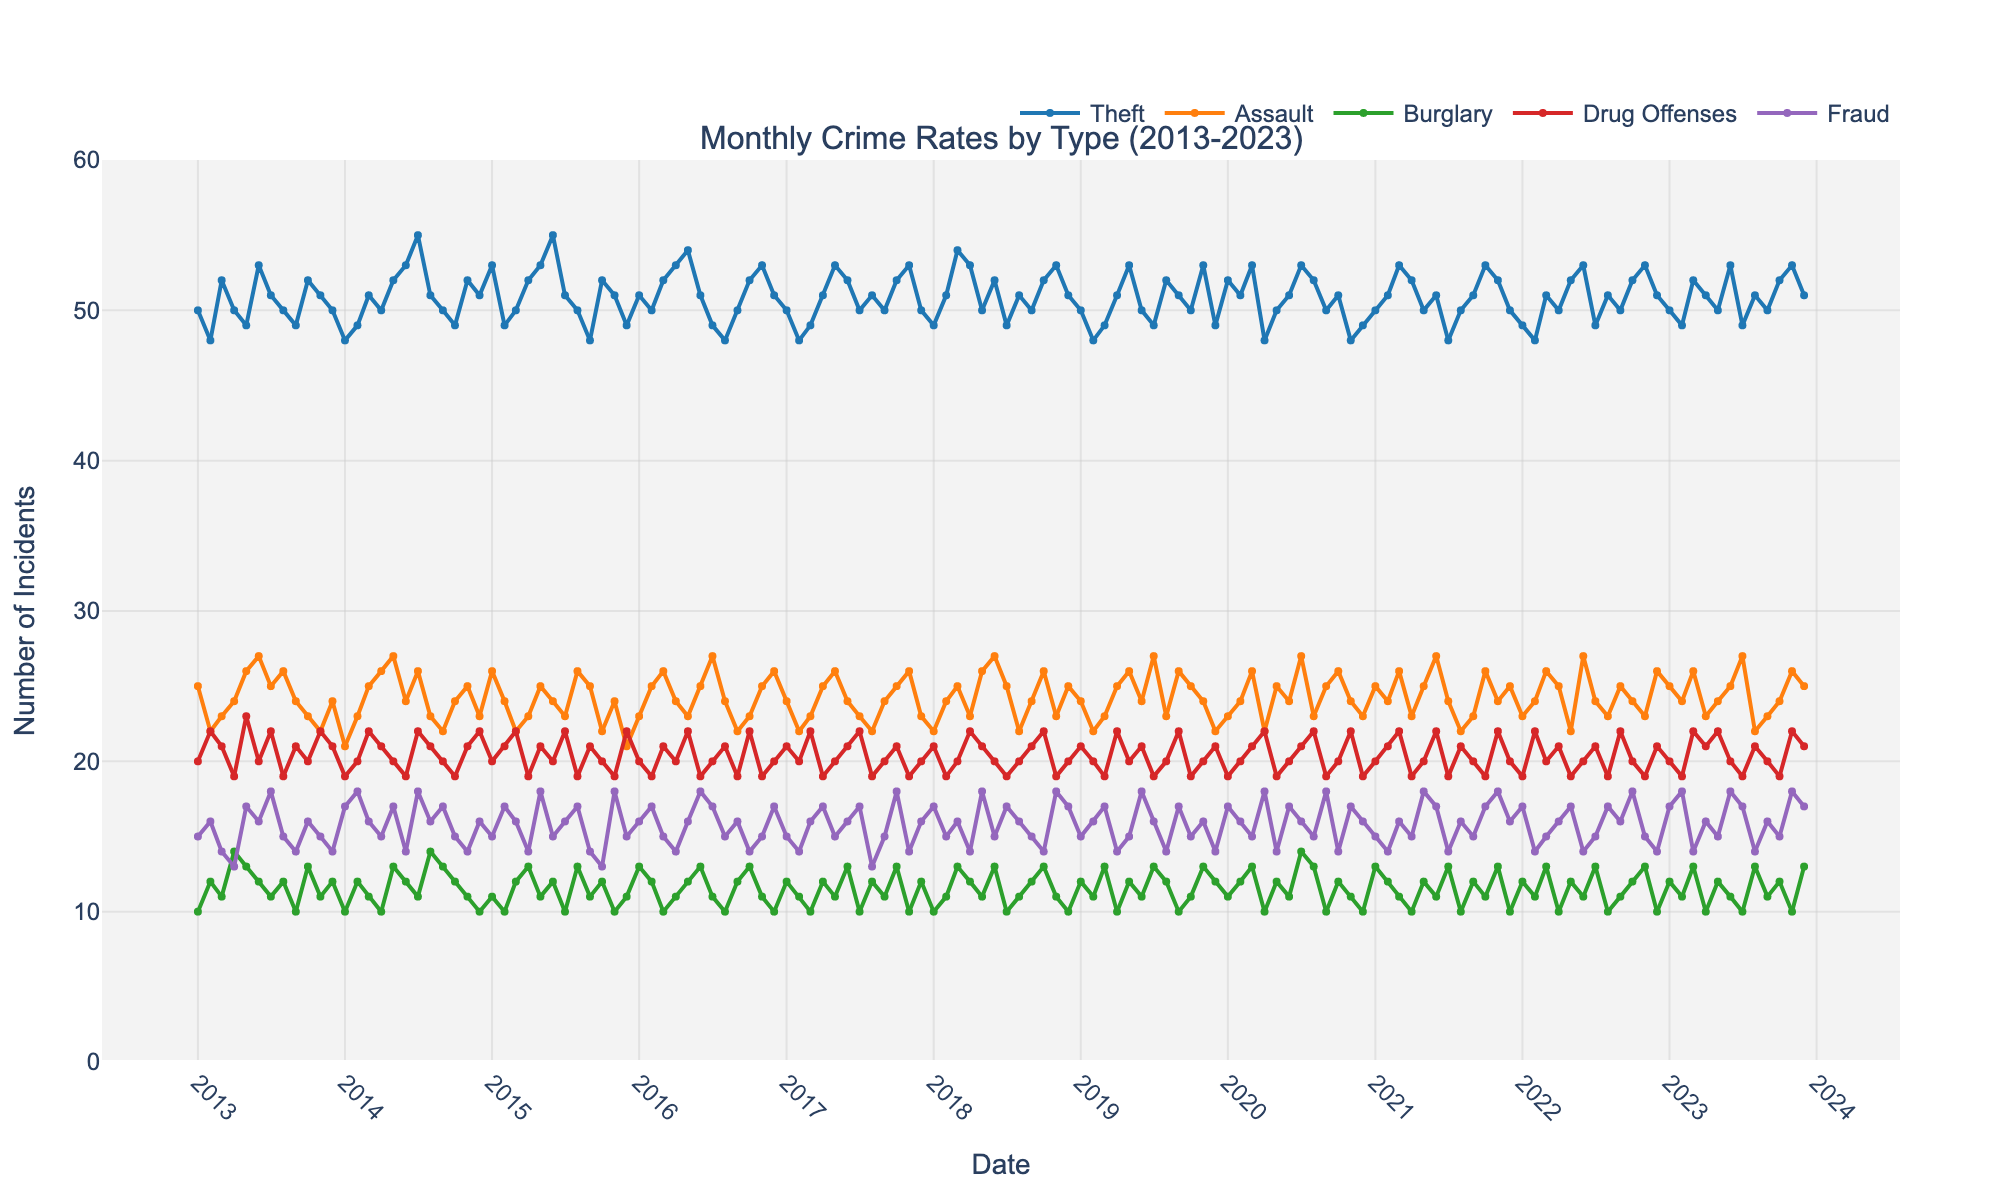What's the title of the plot? The title of the plot is located at the top of the figure owing to typical plotting conventions. It is explicitly stated in the code used to generate the plot.
Answer: Monthly Crime Rates by Type (2013-2023) Which crime type has the highest number of incidents most frequently? By examining the y-axes corresponding to different lines representing each type of crime over time, we observe the frequency and peak values. Theft consistently appears higher than other crime types most frequently.
Answer: Theft How many crime types are tracked in the plot? There are different lines for each crime type, and examining the legend at the top helps us identify them. The legend shows five distinct crime types.
Answer: 5 What is the trend for 'Drug Offenses' over the plotted period? Observing the line for 'Drug Offenses' from the beginning to the end of the timeframe helps visualize its trend. The trend shows moderate fluctuation without significant prolonged upward or downward movement.
Answer: Moderate fluctuation Which month and year had the highest number of drug offenses recorded? To find the peak point on the 'Drug Offenses' line and locating its corresponding month and year, the highest peak is significantly visualized as around July 2021 and July 2022.
Answer: July 2021, July 2022 Which crime type showed a notable peak in the month of July 2020? Looking at the data points corresponding to July 2020 for the different crime type lines, 'Assault' distinctly peaks during this month.
Answer: Assault During which year does 'Burglary' seem to have the most consistent number of incidents? Observing each year's trendline for 'Burglary' and identifying where there is less deviation month-to-month indicates a consistent pattern which is seen around 2013-2014.
Answer: 2013-2014 By how much did incidents of 'Fraud' increase or decrease from January 2013 to January 2023? The 'Fraud' line's initial and terminal values over the given months give the exact points to calculate the difference. It increased from 15 in January 2013 to 17 in January 2023. So, the increased value is 17-15 = 2.
Answer: 2 How does the count of 'Theft' incidents in June 2023 compare with June 2013? Checking the points for 'Theft' in June 2023 and June 2013 will allow comparison - it is 53 in both years indicating no change.
Answer: No change 